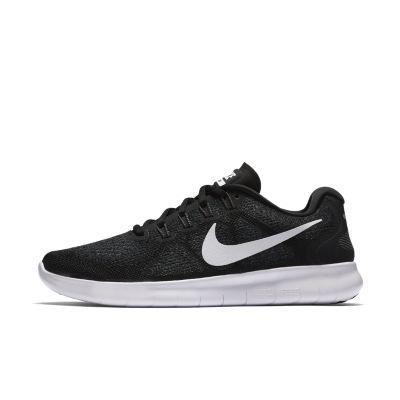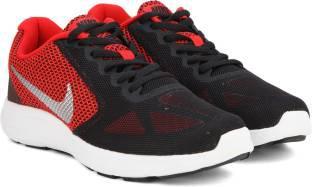The first image is the image on the left, the second image is the image on the right. For the images shown, is this caption "The shoes are flat on the ground and sitting right next to each other in the right image." true? Answer yes or no. Yes. The first image is the image on the left, the second image is the image on the right. For the images shown, is this caption "One image shows a matching pair of shoe facing the right." true? Answer yes or no. Yes. 